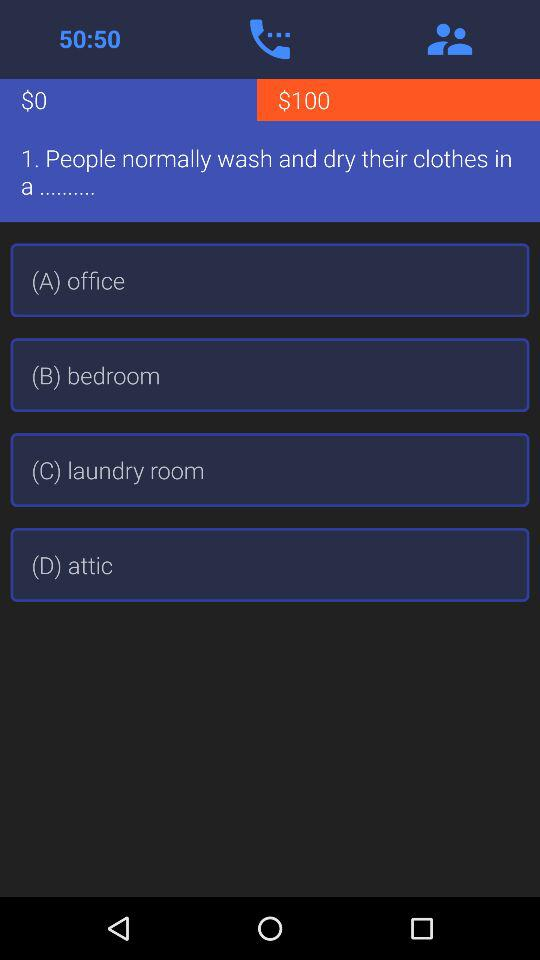What are the available options? The available options are "(A) office", "(B) bedroom", "(C) laundry room" and "(D) attic". 